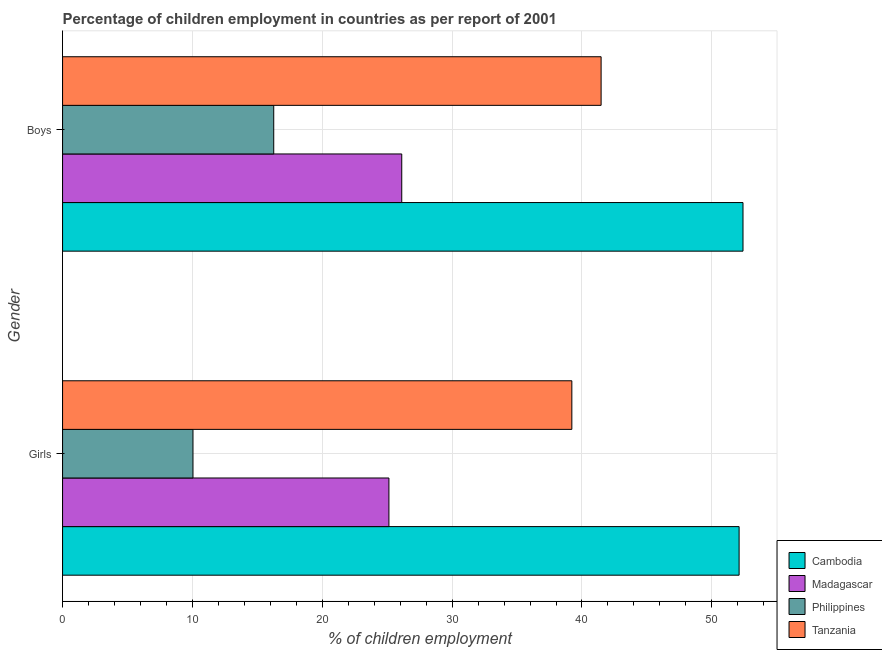How many groups of bars are there?
Your answer should be very brief. 2. Are the number of bars per tick equal to the number of legend labels?
Offer a very short reply. Yes. How many bars are there on the 1st tick from the top?
Your response must be concise. 4. How many bars are there on the 1st tick from the bottom?
Your answer should be compact. 4. What is the label of the 1st group of bars from the top?
Provide a short and direct response. Boys. What is the percentage of employed girls in Madagascar?
Provide a short and direct response. 25.13. Across all countries, what is the maximum percentage of employed girls?
Keep it short and to the point. 52.1. Across all countries, what is the minimum percentage of employed boys?
Offer a terse response. 16.26. In which country was the percentage of employed girls maximum?
Offer a terse response. Cambodia. What is the total percentage of employed boys in the graph?
Offer a very short reply. 136.26. What is the difference between the percentage of employed girls in Cambodia and that in Philippines?
Offer a terse response. 42.06. What is the difference between the percentage of employed girls in Tanzania and the percentage of employed boys in Madagascar?
Your answer should be compact. 13.1. What is the average percentage of employed girls per country?
Ensure brevity in your answer.  31.62. What is the difference between the percentage of employed boys and percentage of employed girls in Philippines?
Provide a succinct answer. 6.22. What is the ratio of the percentage of employed boys in Philippines to that in Tanzania?
Your response must be concise. 0.39. Is the percentage of employed boys in Cambodia less than that in Madagascar?
Provide a short and direct response. No. What does the 3rd bar from the top in Boys represents?
Provide a succinct answer. Madagascar. What does the 1st bar from the bottom in Girls represents?
Your response must be concise. Cambodia. How many bars are there?
Give a very brief answer. 8. Are all the bars in the graph horizontal?
Keep it short and to the point. Yes. How are the legend labels stacked?
Your answer should be very brief. Vertical. What is the title of the graph?
Make the answer very short. Percentage of children employment in countries as per report of 2001. Does "Faeroe Islands" appear as one of the legend labels in the graph?
Ensure brevity in your answer.  No. What is the label or title of the X-axis?
Offer a very short reply. % of children employment. What is the % of children employment in Cambodia in Girls?
Offer a very short reply. 52.1. What is the % of children employment in Madagascar in Girls?
Ensure brevity in your answer.  25.13. What is the % of children employment in Philippines in Girls?
Offer a terse response. 10.04. What is the % of children employment of Tanzania in Girls?
Offer a very short reply. 39.22. What is the % of children employment of Cambodia in Boys?
Make the answer very short. 52.4. What is the % of children employment of Madagascar in Boys?
Offer a terse response. 26.12. What is the % of children employment in Philippines in Boys?
Offer a very short reply. 16.26. What is the % of children employment in Tanzania in Boys?
Offer a terse response. 41.47. Across all Gender, what is the maximum % of children employment of Cambodia?
Provide a short and direct response. 52.4. Across all Gender, what is the maximum % of children employment of Madagascar?
Provide a short and direct response. 26.12. Across all Gender, what is the maximum % of children employment of Philippines?
Give a very brief answer. 16.26. Across all Gender, what is the maximum % of children employment of Tanzania?
Offer a terse response. 41.47. Across all Gender, what is the minimum % of children employment in Cambodia?
Keep it short and to the point. 52.1. Across all Gender, what is the minimum % of children employment of Madagascar?
Provide a short and direct response. 25.13. Across all Gender, what is the minimum % of children employment of Philippines?
Provide a succinct answer. 10.04. Across all Gender, what is the minimum % of children employment in Tanzania?
Give a very brief answer. 39.22. What is the total % of children employment of Cambodia in the graph?
Provide a succinct answer. 104.5. What is the total % of children employment in Madagascar in the graph?
Give a very brief answer. 51.25. What is the total % of children employment in Philippines in the graph?
Provide a succinct answer. 26.31. What is the total % of children employment in Tanzania in the graph?
Make the answer very short. 80.69. What is the difference between the % of children employment in Cambodia in Girls and that in Boys?
Keep it short and to the point. -0.3. What is the difference between the % of children employment of Madagascar in Girls and that in Boys?
Ensure brevity in your answer.  -0.99. What is the difference between the % of children employment in Philippines in Girls and that in Boys?
Make the answer very short. -6.22. What is the difference between the % of children employment of Tanzania in Girls and that in Boys?
Provide a succinct answer. -2.25. What is the difference between the % of children employment of Cambodia in Girls and the % of children employment of Madagascar in Boys?
Provide a succinct answer. 25.98. What is the difference between the % of children employment of Cambodia in Girls and the % of children employment of Philippines in Boys?
Give a very brief answer. 35.84. What is the difference between the % of children employment in Cambodia in Girls and the % of children employment in Tanzania in Boys?
Your answer should be very brief. 10.63. What is the difference between the % of children employment in Madagascar in Girls and the % of children employment in Philippines in Boys?
Keep it short and to the point. 8.87. What is the difference between the % of children employment in Madagascar in Girls and the % of children employment in Tanzania in Boys?
Offer a terse response. -16.34. What is the difference between the % of children employment of Philippines in Girls and the % of children employment of Tanzania in Boys?
Provide a short and direct response. -31.43. What is the average % of children employment in Cambodia per Gender?
Your answer should be very brief. 52.25. What is the average % of children employment in Madagascar per Gender?
Your answer should be compact. 25.63. What is the average % of children employment in Philippines per Gender?
Offer a very short reply. 13.15. What is the average % of children employment in Tanzania per Gender?
Offer a very short reply. 40.35. What is the difference between the % of children employment in Cambodia and % of children employment in Madagascar in Girls?
Make the answer very short. 26.97. What is the difference between the % of children employment of Cambodia and % of children employment of Philippines in Girls?
Your response must be concise. 42.06. What is the difference between the % of children employment in Cambodia and % of children employment in Tanzania in Girls?
Keep it short and to the point. 12.88. What is the difference between the % of children employment in Madagascar and % of children employment in Philippines in Girls?
Make the answer very short. 15.09. What is the difference between the % of children employment in Madagascar and % of children employment in Tanzania in Girls?
Your answer should be very brief. -14.09. What is the difference between the % of children employment in Philippines and % of children employment in Tanzania in Girls?
Your response must be concise. -29.18. What is the difference between the % of children employment of Cambodia and % of children employment of Madagascar in Boys?
Provide a short and direct response. 26.28. What is the difference between the % of children employment in Cambodia and % of children employment in Philippines in Boys?
Give a very brief answer. 36.14. What is the difference between the % of children employment of Cambodia and % of children employment of Tanzania in Boys?
Ensure brevity in your answer.  10.93. What is the difference between the % of children employment of Madagascar and % of children employment of Philippines in Boys?
Provide a succinct answer. 9.86. What is the difference between the % of children employment in Madagascar and % of children employment in Tanzania in Boys?
Offer a very short reply. -15.35. What is the difference between the % of children employment in Philippines and % of children employment in Tanzania in Boys?
Your answer should be very brief. -25.21. What is the ratio of the % of children employment in Madagascar in Girls to that in Boys?
Make the answer very short. 0.96. What is the ratio of the % of children employment of Philippines in Girls to that in Boys?
Make the answer very short. 0.62. What is the ratio of the % of children employment in Tanzania in Girls to that in Boys?
Keep it short and to the point. 0.95. What is the difference between the highest and the second highest % of children employment in Cambodia?
Your answer should be very brief. 0.3. What is the difference between the highest and the second highest % of children employment of Madagascar?
Offer a terse response. 0.99. What is the difference between the highest and the second highest % of children employment of Philippines?
Give a very brief answer. 6.22. What is the difference between the highest and the second highest % of children employment in Tanzania?
Your answer should be very brief. 2.25. What is the difference between the highest and the lowest % of children employment of Madagascar?
Your response must be concise. 0.99. What is the difference between the highest and the lowest % of children employment of Philippines?
Your answer should be compact. 6.22. What is the difference between the highest and the lowest % of children employment in Tanzania?
Your response must be concise. 2.25. 